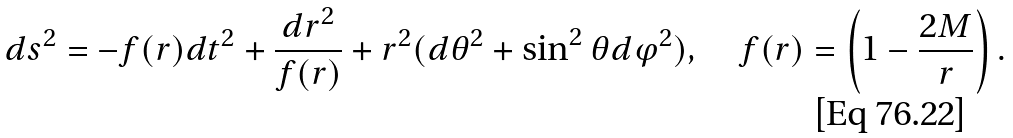<formula> <loc_0><loc_0><loc_500><loc_500>d s ^ { 2 } = - f ( r ) d t ^ { 2 } + \frac { d r ^ { 2 } } { f ( r ) } + r ^ { 2 } ( d \theta ^ { 2 } + \sin ^ { 2 } \theta d \varphi ^ { 2 } ) , \quad f ( r ) = \left ( 1 - \frac { 2 M } r \right ) .</formula> 